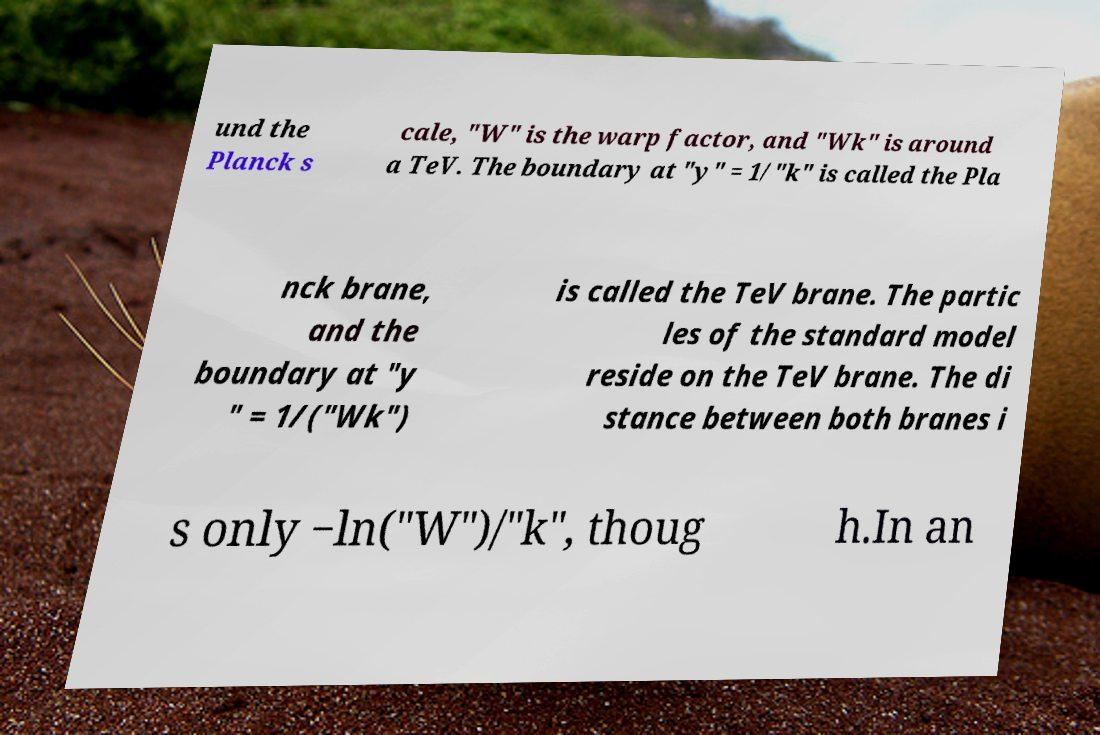I need the written content from this picture converted into text. Can you do that? und the Planck s cale, "W" is the warp factor, and "Wk" is around a TeV. The boundary at "y" = 1/"k" is called the Pla nck brane, and the boundary at "y " = 1/("Wk") is called the TeV brane. The partic les of the standard model reside on the TeV brane. The di stance between both branes i s only −ln("W")/"k", thoug h.In an 